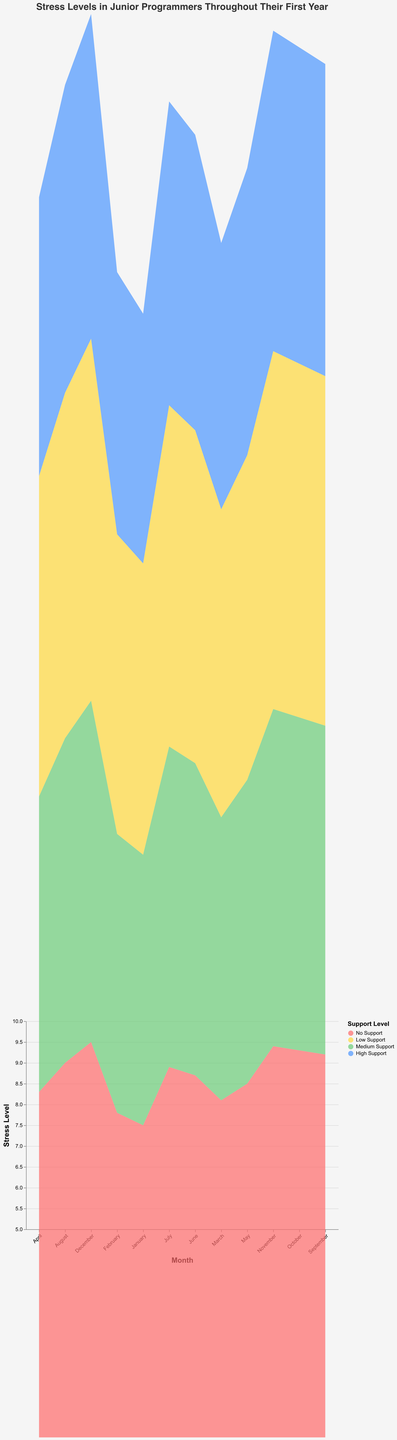How does the stress level change for junior programmers without any support over the year? To answer this, look at the shaded area labeled "No Support." Starting from January with a stress level of 7.5, it consistently increases each month, reaching 9.5 by December. So, stress levels rise steadily throughout the year without any support.
Answer: The stress level increases from 7.5 to 9.5 Which month shows the highest stress level for junior programmers with high support? Examine the highest point of the "High Support" area. In December, it reaches its maximum value of 7.8, indicating this month has the highest stress level.
Answer: December What is the difference in stress levels between high support and no support in June? The stress level with high support in June is 7.1, and with no support, it is 8.7. The difference is 8.7 - 7.1 = 1.6.
Answer: 1.6 Compare the stress levels for low support and medium support in September. Which is higher and by how much? The stress level for low support in September is 8.4, and for medium support, it is 7.9. The difference is 8.4 - 7.9 = 0.5, making low support higher by 0.5.
Answer: Low support, higher by 0.5 How does the range of stress levels for junior programmers differ between high and no support over the year? The range for high support is from 6.0 in January to 7.8 in December, a difference of 1.8. For no support, the range is from 7.5 in January to 9.5 in December, a difference of 2.0. So, the range for no support is broader by 0.2.
Answer: Broader by 0.2 What is the average stress level for junior programmers with medium support in the first quarter (January-March)? Add the stress levels for January, February, and March for medium support (6.5 + 6.7 + 6.8) = 20. Divide by the number of months (3). So, the average is 20 / 3 ≈ 6.67.
Answer: ≈ 6.67 Which support level shows the most significant increase in stress levels from April to May? Calculate the difference for each support level between April and May. For no support: 8.5 - 8.3 = 0.2, for low support: 7.8 - 7.7 = 0.1, for medium support: 7.3 - 7.1 = 0.2, and for high support: 6.9 - 6.7 = 0.2. All support levels show the same maximum increase of 0.2.
Answer: No support, medium support, and high support (tied at 0.2) Are there any months where the stress levels for low and medium support are the same? By scanning through the chart data, there are no months where the stress levels for low and medium support have the same value.
Answer: No What overall trend can be observed for stress levels in all support levels over the year? All support levels show an increasing trend. Stress levels rise steadily from January to December, although the rates differ significantly depending on the support level, with less support resulting in higher stress levels.
Answer: Stress levels steadily rise in all support levels 